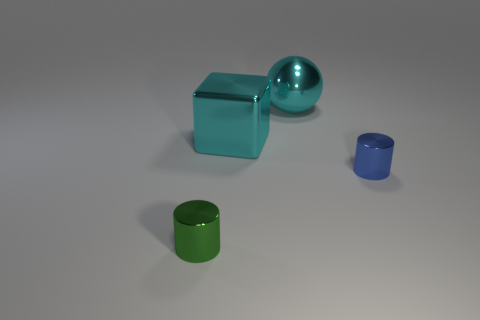Add 3 tiny green shiny cylinders. How many objects exist? 7 Subtract 0 red cubes. How many objects are left? 4 Subtract all cubes. How many objects are left? 3 Subtract all cyan cylinders. Subtract all purple spheres. How many cylinders are left? 2 Subtract all large purple spheres. Subtract all blue cylinders. How many objects are left? 3 Add 4 cyan shiny objects. How many cyan shiny objects are left? 6 Add 1 yellow matte things. How many yellow matte things exist? 1 